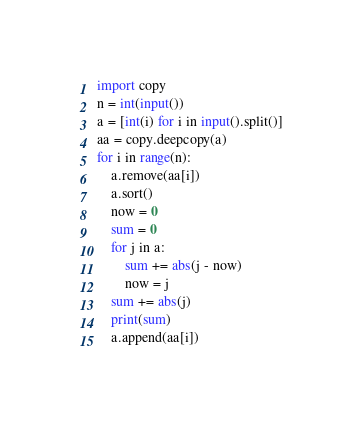Convert code to text. <code><loc_0><loc_0><loc_500><loc_500><_Python_>import copy
n = int(input())
a = [int(i) for i in input().split()]
aa = copy.deepcopy(a)
for i in range(n):
	a.remove(aa[i])
	a.sort()
	now = 0
	sum = 0
	for j in a:
		sum += abs(j - now)
		now = j
	sum += abs(j)
	print(sum)
	a.append(aa[i])
</code> 